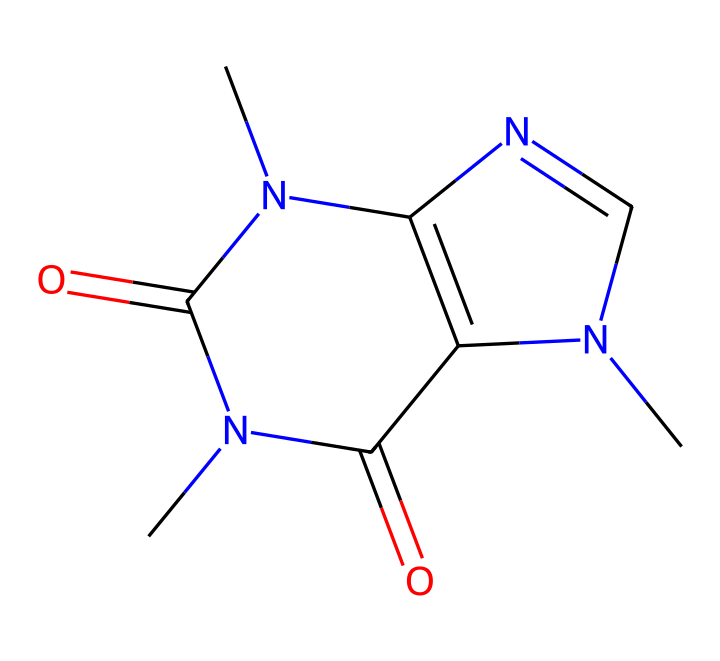What is the molecular formula of caffeine? To determine the molecular formula from the SMILES representation, we need to identify each type of atom present in the structure. The representation indicates there are 8 carbon (C) atoms, 10 hydrogen (H) atoms, 4 nitrogen (N) atoms, and 2 oxygen (O) atoms, leading to the molecular formula of C8H10N4O2.
Answer: C8H10N4O2 How many nitrogen atoms are in the caffeine structure? By examining the SMILES representation, we can count the nitrogen (N) atoms present. The representation shows 4 distinct nitrogen atoms within the structure of caffeine.
Answer: 4 What type of chemical compound is caffeine classified as? Looking at the structure provided in the SMILES, caffeine is classified as an alkaloid compound, which are typically nitrogen-containing compounds with biological activity.
Answer: alkaloid What kind of functional groups are indicated in the caffeine structure? Analyzing the chemical structure, we see that caffeine contains amide functional groups, which can be identified by the presence of the carbonyl group (C=O) bonded to a nitrogen atom (N).
Answer: amide What is the role of the carbonyl group in caffeine? The carbonyl group (C=O) in caffeine is crucial for its biological activity and can influence its solubility and interaction with biological receptors. This functional group is often associated with the ability of compounds to form hydrogen bonds.
Answer: biological activity Does caffeine contain aliphatic or aromatic components? The structure depicted contains both aliphatic and aromatic components. The nitrogen-containing rings show aromatic characteristics, while other parts of the molecule exhibit aliphatic attributes.
Answer: both 